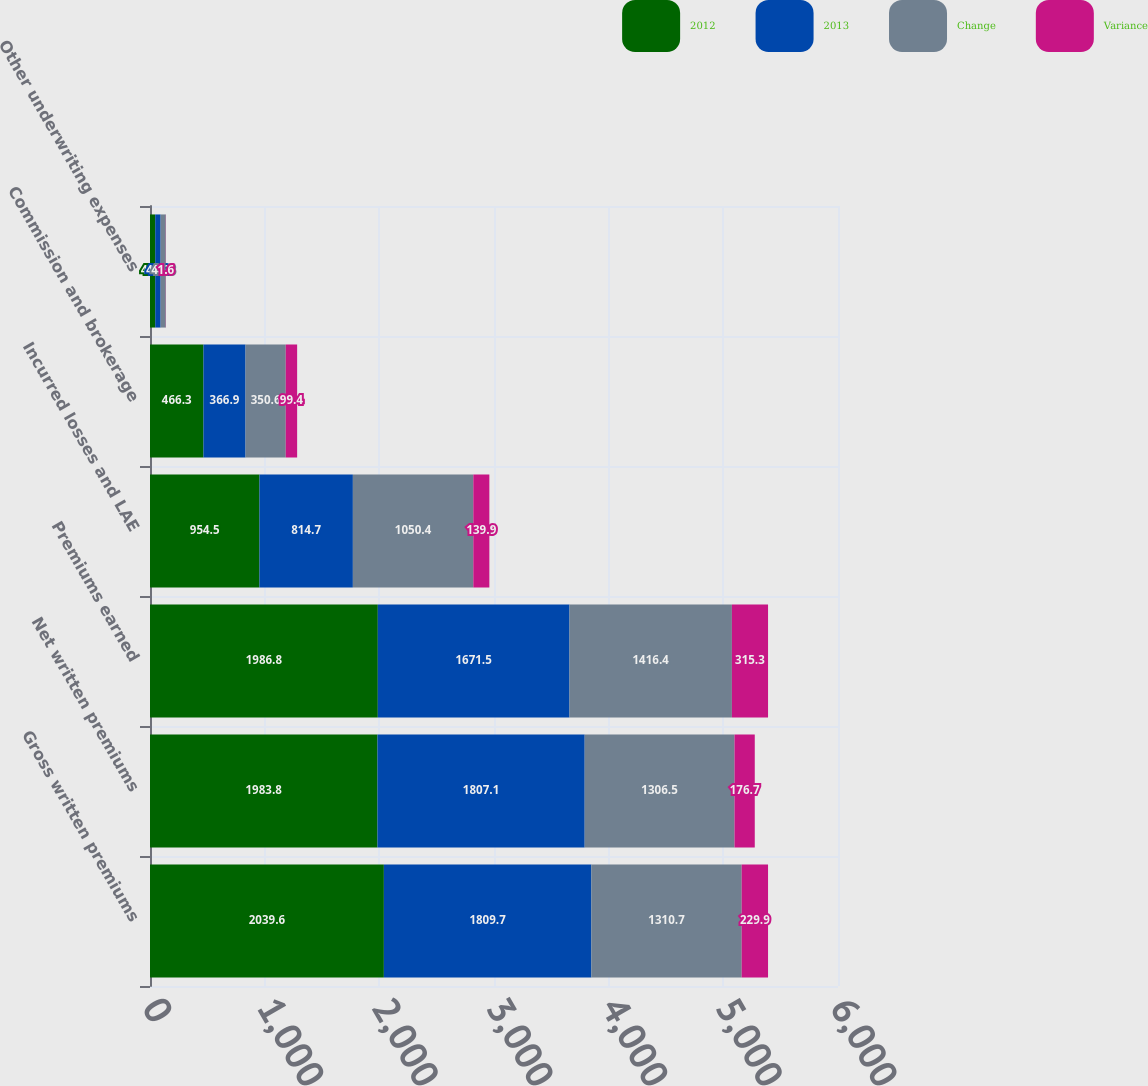<chart> <loc_0><loc_0><loc_500><loc_500><stacked_bar_chart><ecel><fcel>Gross written premiums<fcel>Net written premiums<fcel>Premiums earned<fcel>Incurred losses and LAE<fcel>Commission and brokerage<fcel>Other underwriting expenses<nl><fcel>2012<fcel>2039.6<fcel>1983.8<fcel>1986.8<fcel>954.5<fcel>466.3<fcel>45.6<nl><fcel>2013<fcel>1809.7<fcel>1807.1<fcel>1671.5<fcel>814.7<fcel>366.9<fcel>47.2<nl><fcel>Change<fcel>1310.7<fcel>1306.5<fcel>1416.4<fcel>1050.4<fcel>350.6<fcel>44.8<nl><fcel>Variance<fcel>229.9<fcel>176.7<fcel>315.3<fcel>139.9<fcel>99.4<fcel>1.6<nl></chart> 